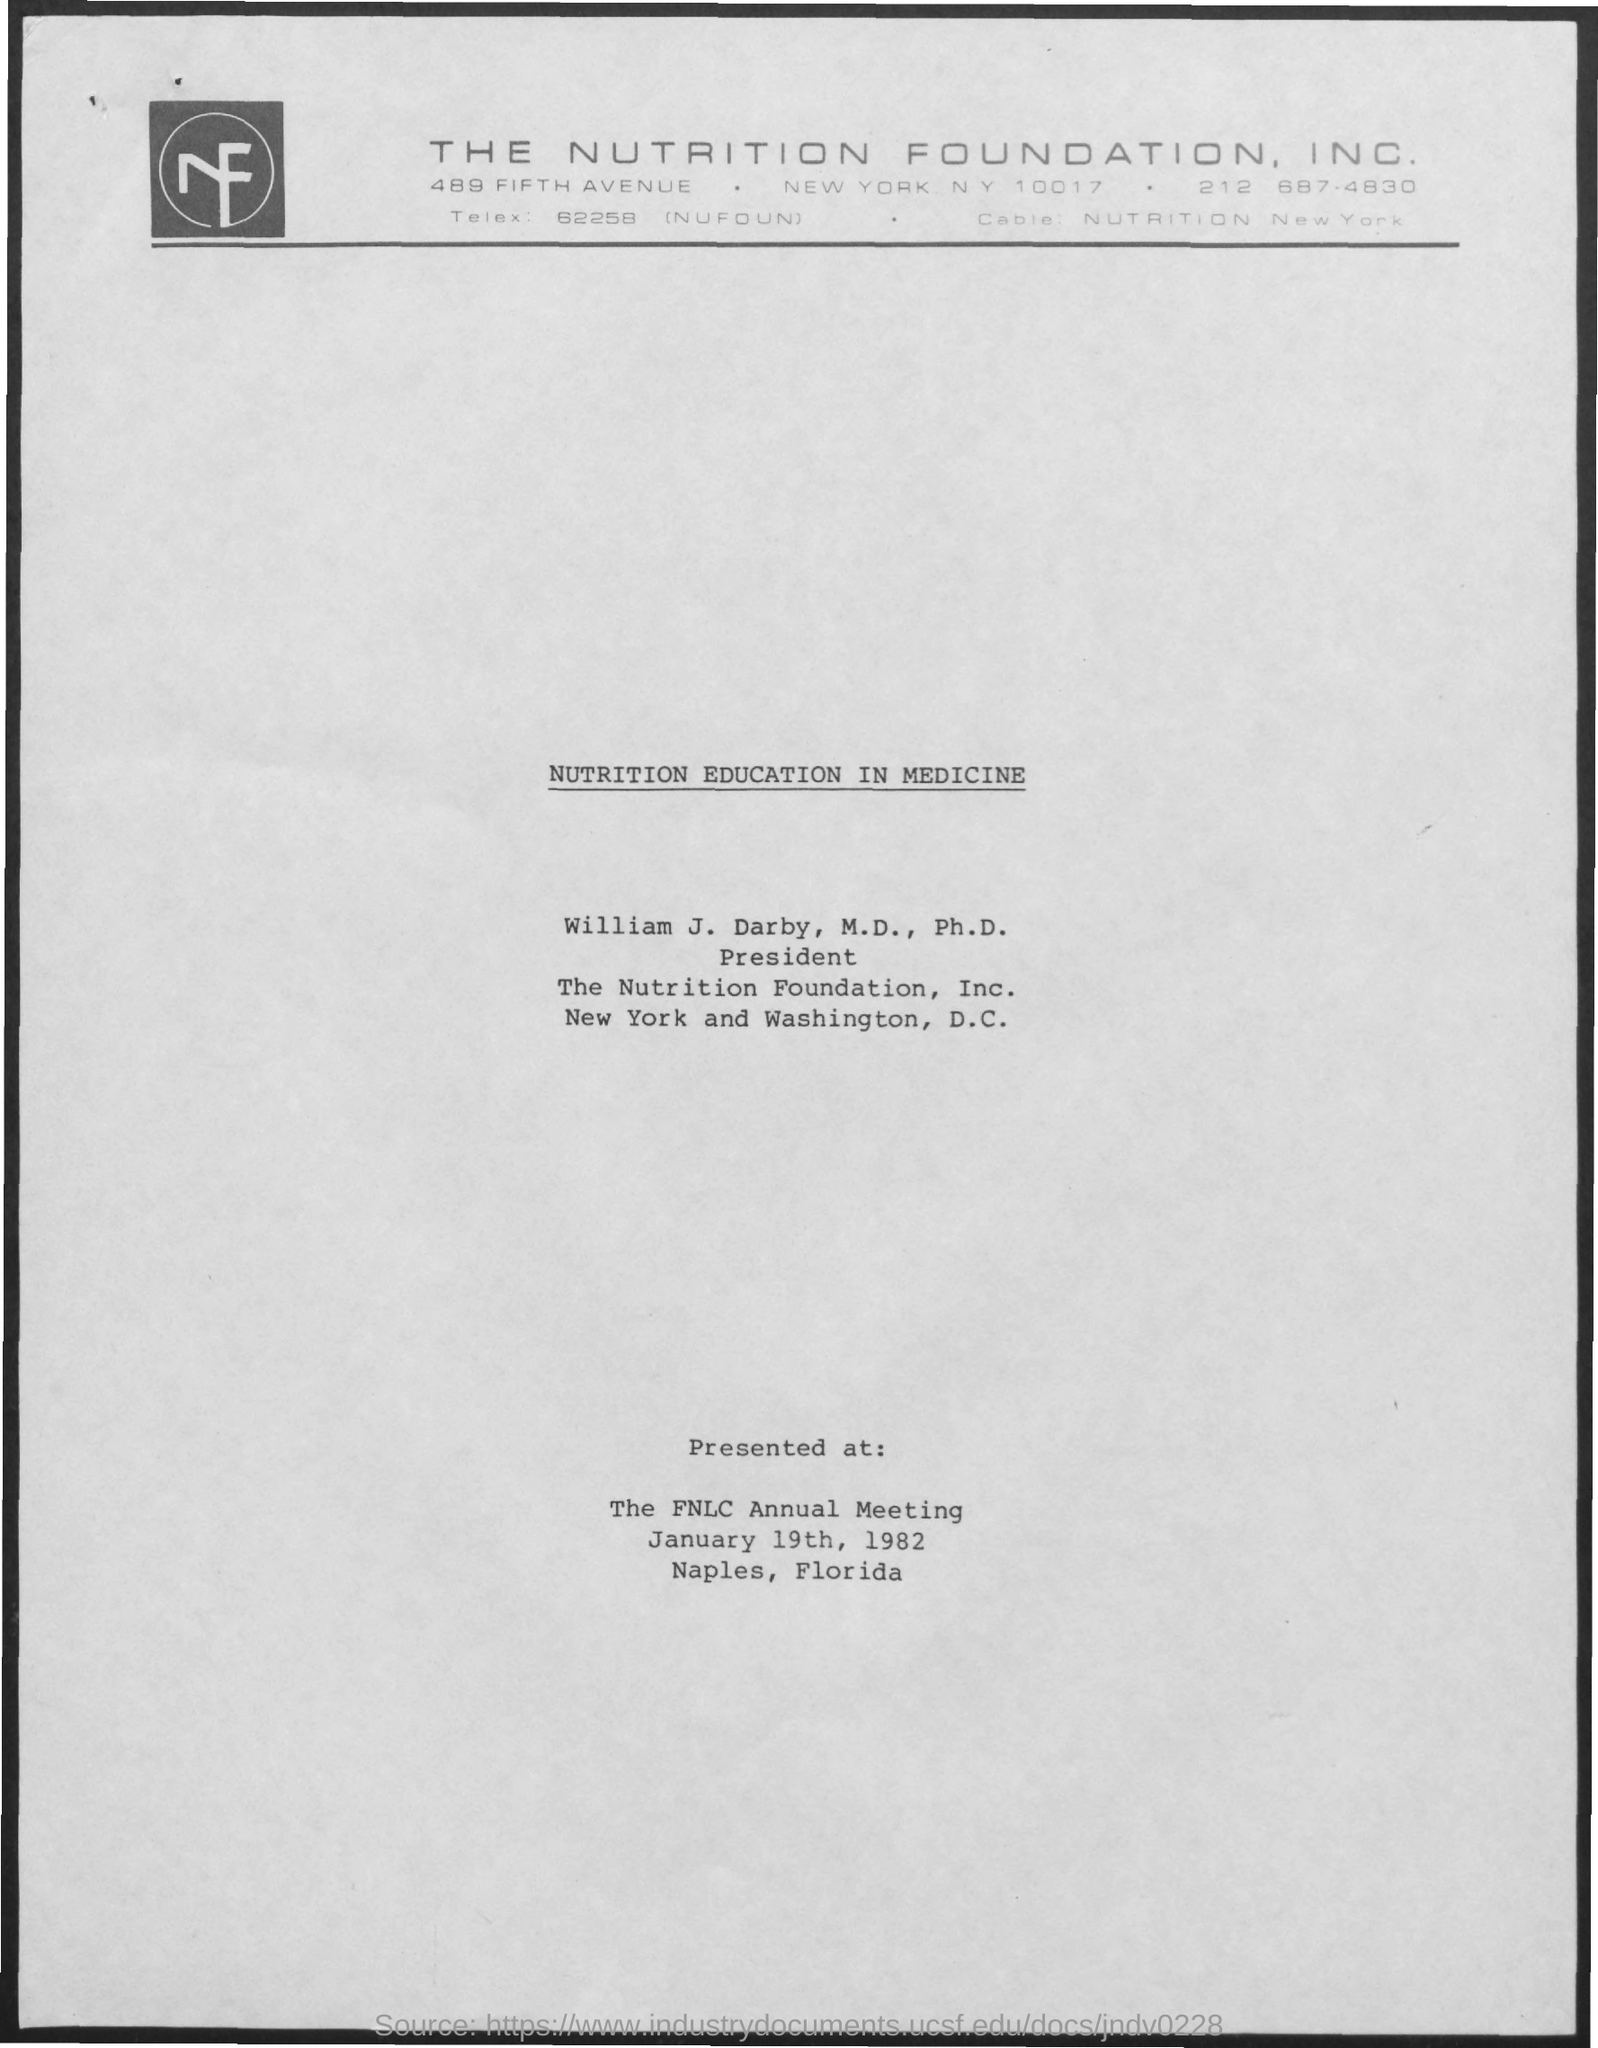Highlight a few significant elements in this photo. The meeting was held on January 19th, 1982. The Nutrition Foundation, Inc. is mentioned. Nutrition education in medicine was presented at the FNLC Annual Meeting. The president of The Nutrition Foundation, Inc. is William J. Darby. The meeting was held in Naples, Florida. 